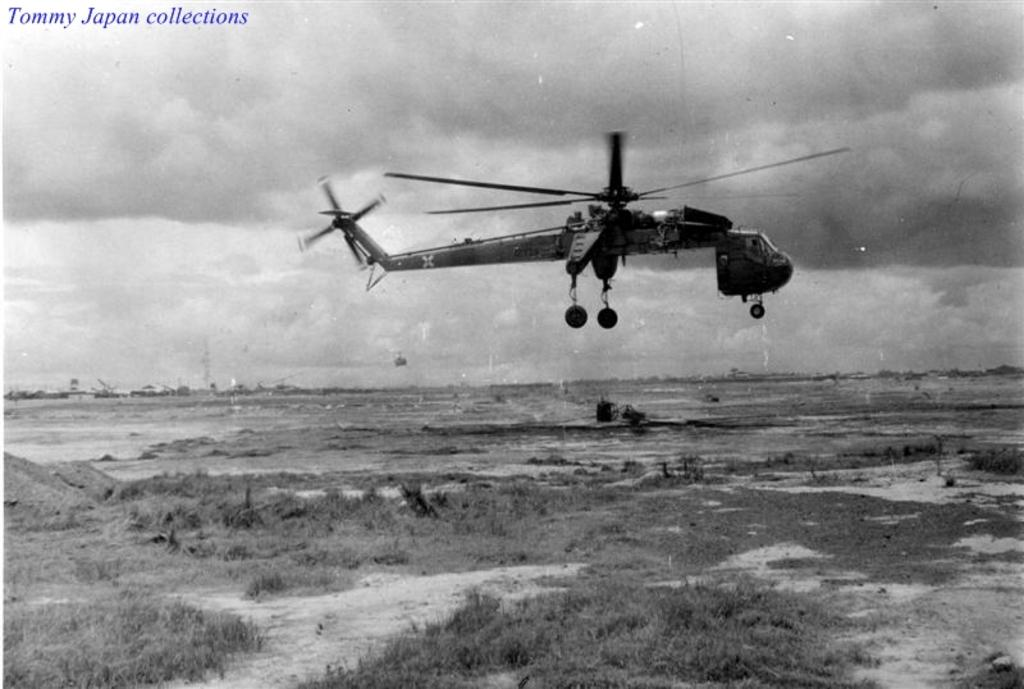What is flying in the sky in the image? There is an airplane flying in the sky in the image. What is on the ground in the image? There is grass on the ground in the image. What can be seen at the top of the image? There is some text visible at the top of the image. How would you describe the sky in the image? The sky is cloudy in the image. What type of engine is being used for driving in the image? There is no driving or engine present in the image; it features an airplane flying in the sky and grass on the ground. Can you tell me which letter is being emphasized in the image? There is no specific letter being emphasized in the image; it only contains some text at the top. 